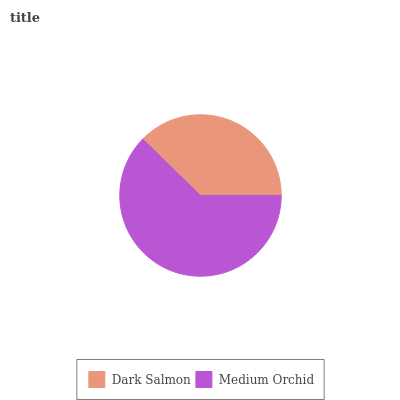Is Dark Salmon the minimum?
Answer yes or no. Yes. Is Medium Orchid the maximum?
Answer yes or no. Yes. Is Medium Orchid the minimum?
Answer yes or no. No. Is Medium Orchid greater than Dark Salmon?
Answer yes or no. Yes. Is Dark Salmon less than Medium Orchid?
Answer yes or no. Yes. Is Dark Salmon greater than Medium Orchid?
Answer yes or no. No. Is Medium Orchid less than Dark Salmon?
Answer yes or no. No. Is Medium Orchid the high median?
Answer yes or no. Yes. Is Dark Salmon the low median?
Answer yes or no. Yes. Is Dark Salmon the high median?
Answer yes or no. No. Is Medium Orchid the low median?
Answer yes or no. No. 